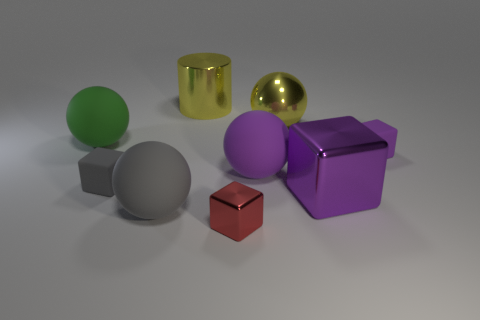What number of large balls are on the left side of the yellow shiny ball and on the right side of the big green rubber object?
Make the answer very short. 2. There is a shiny cube that is in front of the large gray object; is its size the same as the yellow metal thing that is to the right of the purple sphere?
Keep it short and to the point. No. How many objects are rubber balls on the left side of the gray matte ball or large purple blocks?
Your answer should be very brief. 2. What is the material of the big yellow object that is in front of the large metal cylinder?
Keep it short and to the point. Metal. What is the large purple sphere made of?
Ensure brevity in your answer.  Rubber. There is a ball behind the large matte sphere behind the matte thing that is on the right side of the large metal sphere; what is its material?
Your answer should be compact. Metal. Are there any other things that have the same material as the red thing?
Offer a terse response. Yes. There is a gray ball; does it have the same size as the matte block that is on the left side of the red block?
Make the answer very short. No. What number of things are either large matte spheres right of the big yellow cylinder or matte things in front of the gray rubber cube?
Keep it short and to the point. 2. There is a large ball that is in front of the big purple cube; what color is it?
Offer a very short reply. Gray. 